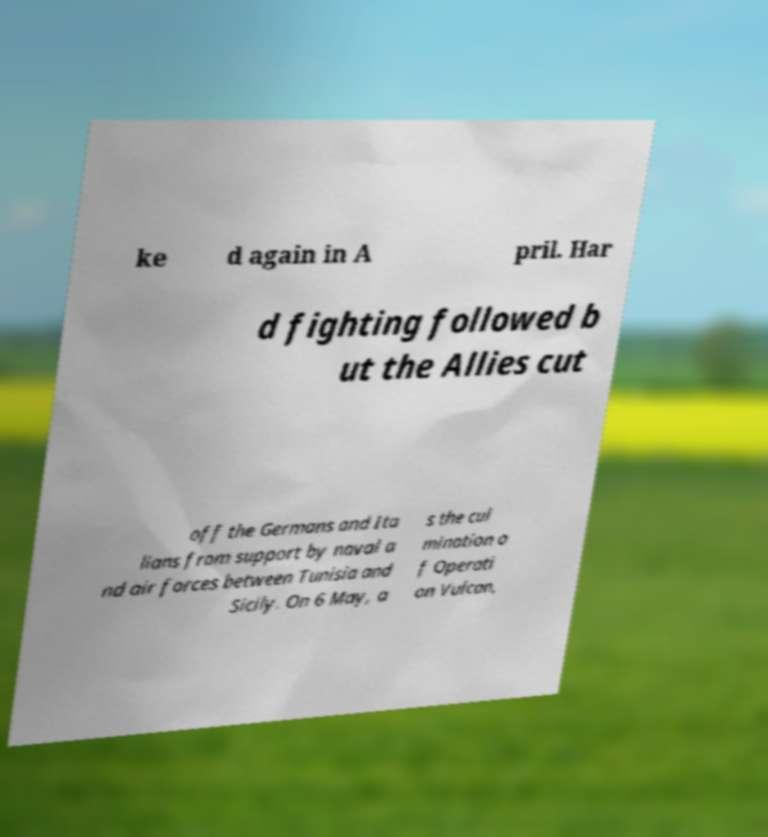Please read and relay the text visible in this image. What does it say? ke d again in A pril. Har d fighting followed b ut the Allies cut off the Germans and Ita lians from support by naval a nd air forces between Tunisia and Sicily. On 6 May, a s the cul mination o f Operati on Vulcan, 